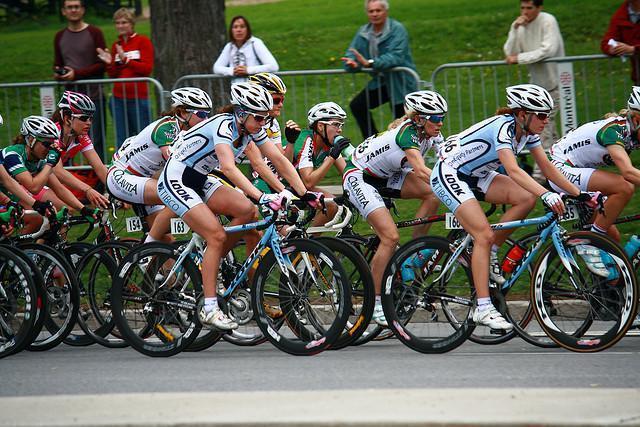How many people are there?
Give a very brief answer. 12. How many bicycles can you see?
Give a very brief answer. 6. How many birds are flying?
Give a very brief answer. 0. 